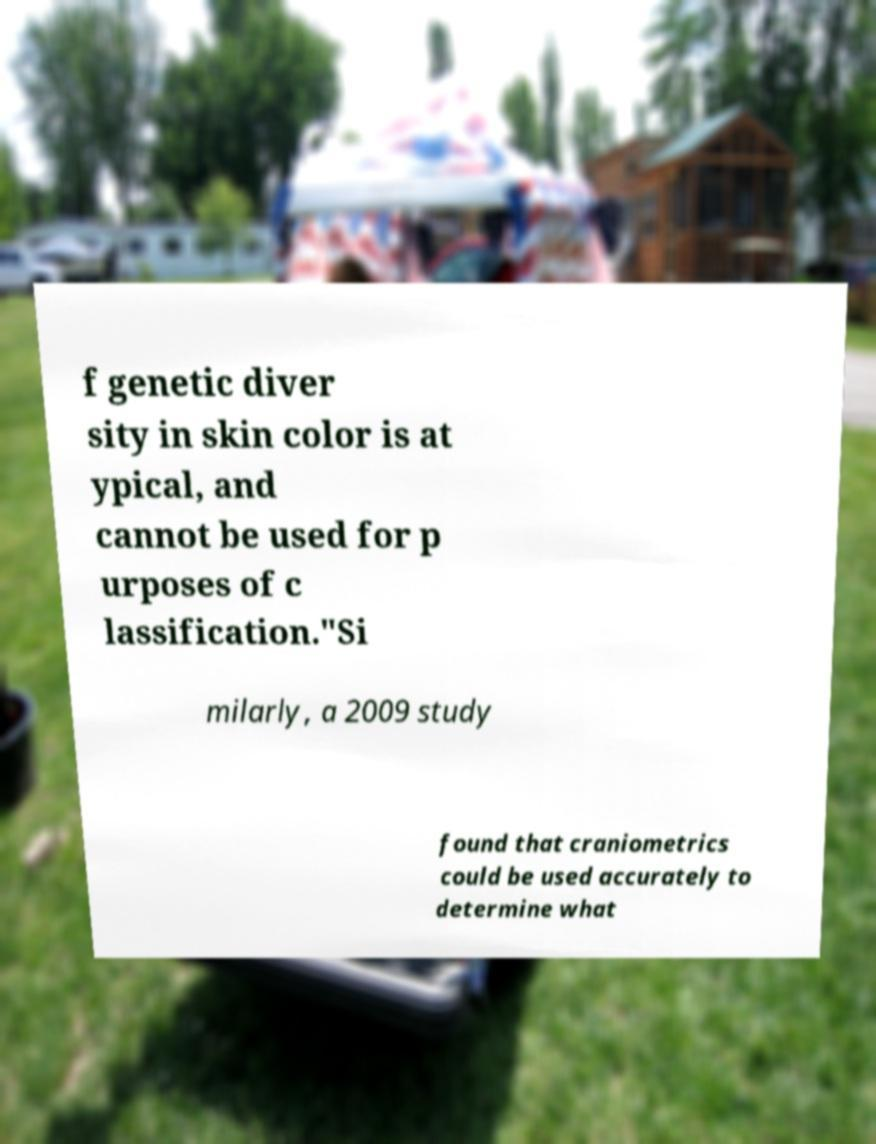Please read and relay the text visible in this image. What does it say? f genetic diver sity in skin color is at ypical, and cannot be used for p urposes of c lassification."Si milarly, a 2009 study found that craniometrics could be used accurately to determine what 